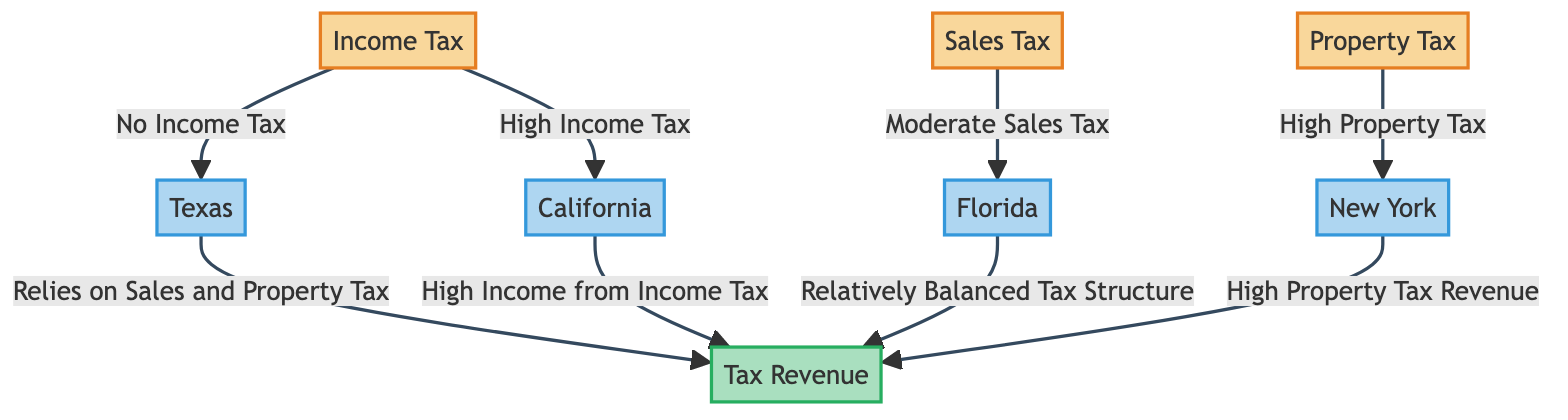What type of tax does Texas not have? The diagram explicitly states "No Income Tax" as the relationship from the income tax node to the Texas node. This direct association indicates that Texas does not impose an income tax.
Answer: No Income Tax Which state relies heavily on income tax revenue? According to the diagram, California is directly linked to high income from income tax, indicating its heavy reliance on income tax revenue.
Answer: California How many different types of taxes are represented in the diagram? The diagram features three distinct tax types: Income Tax, Sales Tax, and Property Tax. Thus, counting each clearly labeled tax type gives a total of three.
Answer: Three What is the relationship between Florida and its sales tax? The diagram notes "Moderate Sales Tax" between the sales tax node and the Florida node. This relationship highlights that Florida's sales tax can be categorized as moderate.
Answer: Moderate Sales Tax Which state has a high property tax revenue? The diagram connects New York with "High Property Tax Revenue," indicating that New York is characterized by high property tax revenue.
Answer: New York What tax structure does Florida have? The diagram states that Florida has a "Relatively Balanced Tax Structure," demonstrating a combination of various tax strategies that maintains balance rather than leaning heavily in one direction.
Answer: Relatively Balanced Tax Structure How does Texas generate its tax revenue? The diagram illustrates that Texas "Relies on Sales and Property Tax" for its tax revenue. This relationship demonstrates the state's preference for these types of taxation instead of income tax.
Answer: Relies on Sales and Property Tax What type of revenue is associated with high property tax in New York? The relationship depicted in the diagram indicates that New York contributes "High Property Tax Revenue" as its tax revenue source, emphasizing the significance of property tax.
Answer: High Property Tax Revenue What can be inferred about California's tax revenue? The diagram states that California has "High Income from Income Tax," which suggests a strong dependency on income tax to generate revenue. This reflects a relatively high tax burden on residents.
Answer: High Income from Income Tax How many states are represented in the diagram? The diagram includes four states: Texas, California, Florida, and New York. Counting each node representing a state confirms the total number of states represented.
Answer: Four 